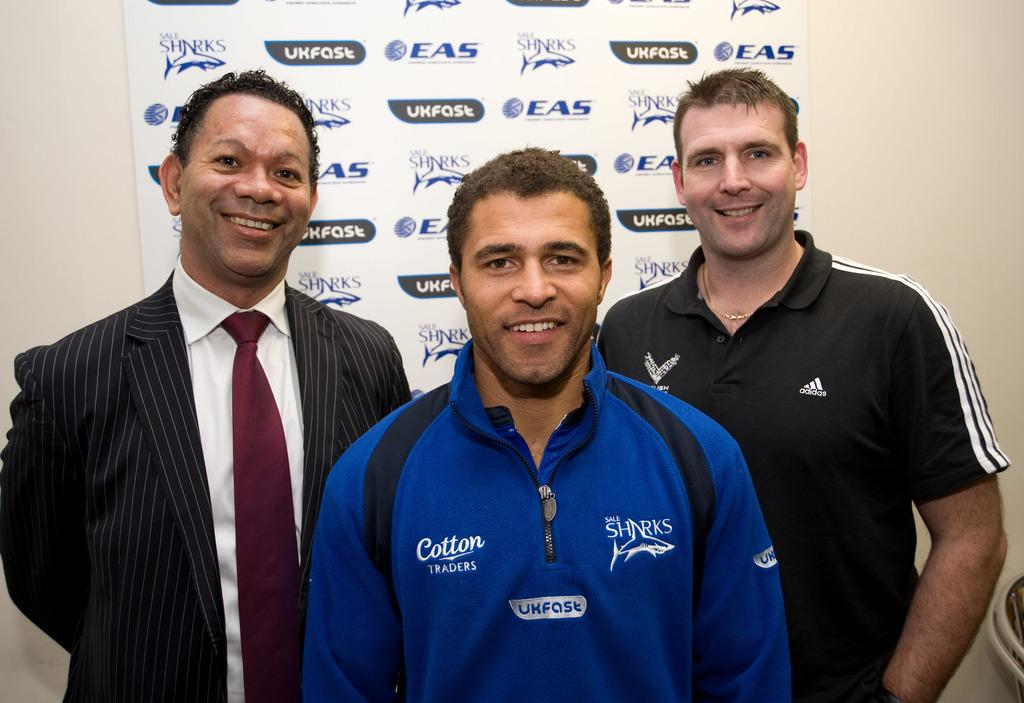<image>
Create a compact narrative representing the image presented. Three men standing in front of a board which contains the letters EAS 